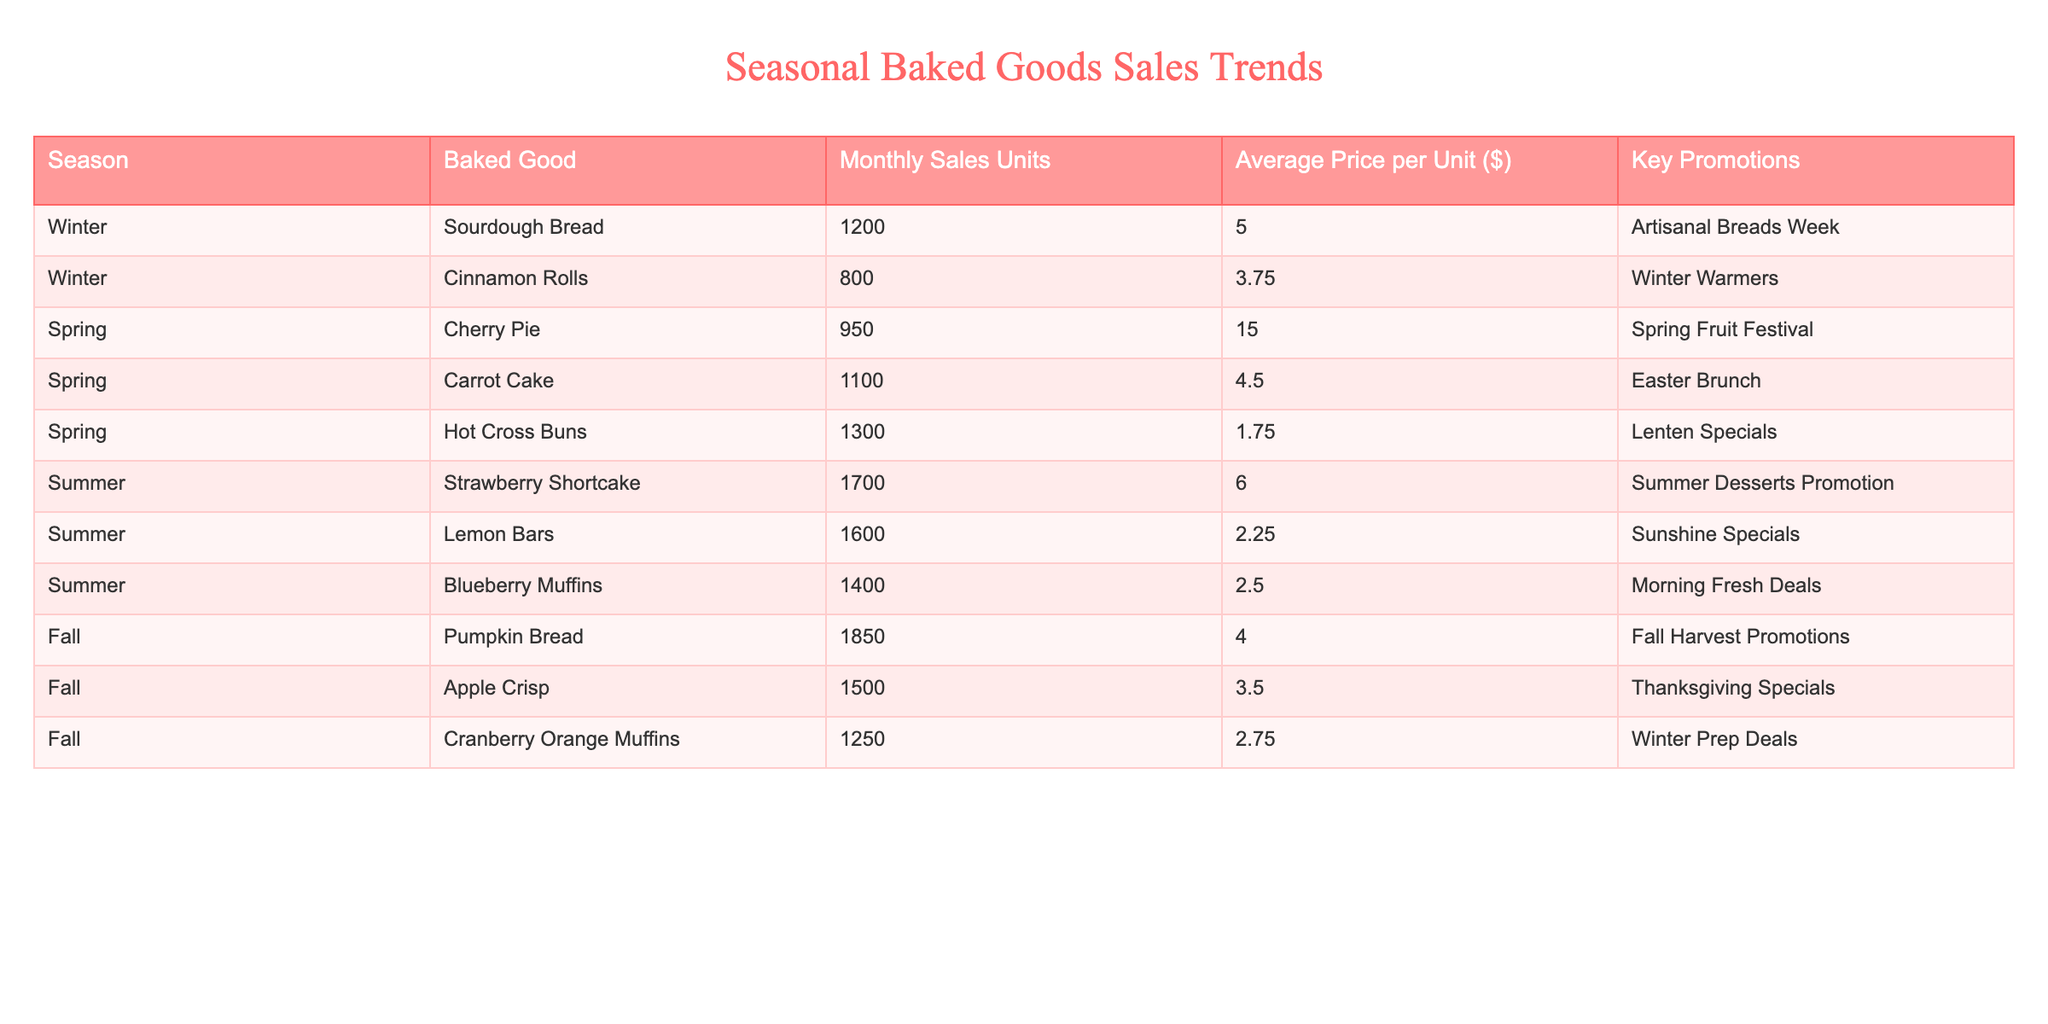What baked good had the highest sales in Winter? By examining the Winter season data, Sourdough Bread has 1200 units sold, while Cinnamon Rolls have 800 units. Therefore, Sourdough Bread has the highest sales.
Answer: Sourdough Bread Which baked good is associated with the highest average price per unit? Comparing the average prices per unit, Cherry Pie is priced at $15.00, which is higher than all other baked goods listed.
Answer: Cherry Pie What is the total sales volume for all baked goods in Summer? The total sales for Summer includes Strawberry Shortcake (1700), Lemon Bars (1600), and Blueberry Muffins (1400). Summing them gives 1700 + 1600 + 1400 = 4700 units.
Answer: 4700 Is the average price of Hot Cross Buns lower than that of Cranberry Orange Muffins? Hot Cross Buns have an average price of $1.75, while Cranberry Orange Muffins are priced at $2.75. Since $1.75 is less than $2.75, the statement is true.
Answer: Yes What is the average sales volume of baked goods in the Fall season? In Fall, the sales figures are Pumpkin Bread (1850), Apple Crisp (1500), and Cranberry Orange Muffins (1250). The total is 1850 + 1500 + 1250 = 4600, and there are 3 items, so the average is 4600 / 3 = 1533.33.
Answer: 1533.33 Which season has the fewest total sales? To find the season with the fewest total sales, we can total Winter (2000), Spring (3350), Summer (4700), and Fall (4600). Winter has the least at 2000 units.
Answer: Winter Are Lemon Bars more frequently sold compared to Apple Crisp during the respective seasons? Lemon Bars sold 1600 units in Summer, while Apple Crisp sold 1500 units in Fall. Therefore, Lemon Bars are more frequently sold.
Answer: Yes What is the difference in sales volume between the best-selling baked good in Fall and the best-selling baked good in Winter? In Fall, Pumpkin Bread leads with 1850 units sold and in Winter, Sourdough Bread leads with 1200 units sold. The difference is 1850 - 1200 = 650 units.
Answer: 650 What promotional event corresponds to the highest selling baked good in Spring? The highest selling baked good in Spring is Hot Cross Buns with 1300 units sold, promoted during the "Lenten Specials" event.
Answer: Lenten Specials 